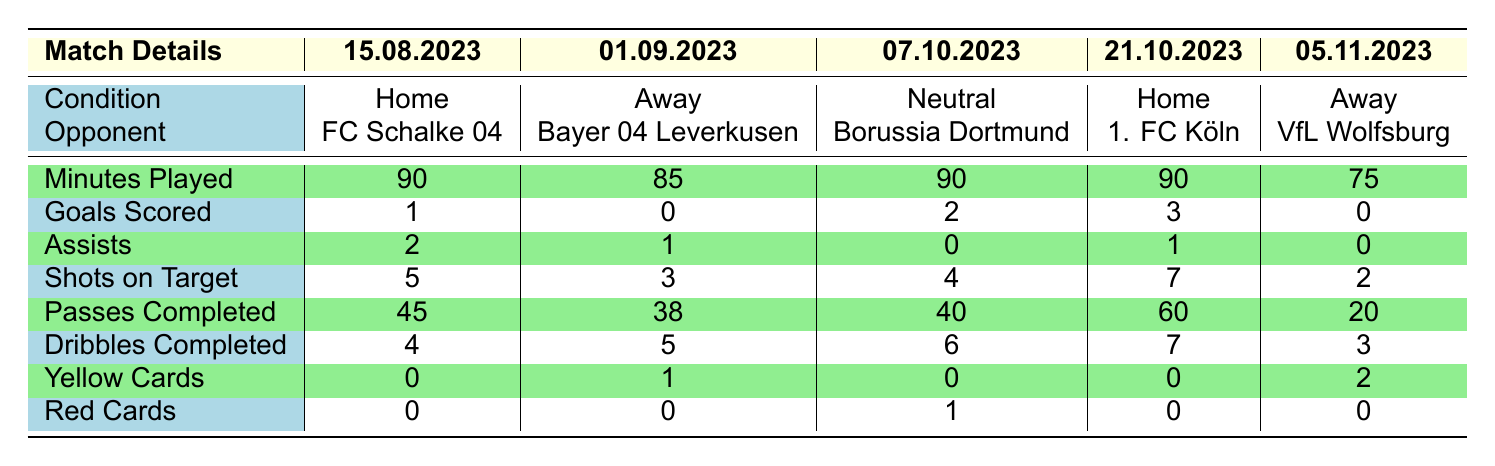What is the total number of goals scored by Jonas Kersken in home games? In the table, there are two home games listed. In the game on 2023-08-15, he scored 1 goal, and in the game on 2023-10-21, he scored 3 goals. So, total goals in home games = 1 + 3 = 4.
Answer: 4 How many assists did Jonas Kersken have in the away game against Bayer 04 Leverkusen? Looking at the relevant row for the away game on 2023-09-01, it shows that he had 1 assist in that match.
Answer: 1 What is the average number of shots on target across all the matches played? To find the average, we sum up all the shots on target: 5 + 3 + 4 + 7 + 2 = 21. There are 5 matches total, so the average = 21 / 5 = 4.2.
Answer: 4.2 Did he receive any red cards in the home game against FC Schalke 04? Checking the relevant row for the home game on 2023-08-15, it shows that he received 0 red cards.
Answer: No Which match condition resulted in the highest number of goals scored by Jonas Kersken? Looking at the goals scored in each match condition, he scored 0 goals in 2 away games, 4 in home games, and 2 in 1 neutral game. Thus, the highest was in home games with 4 goals.
Answer: Home Game What is the total number of yellow cards received by Jonas Kersken in the away matches? There are two away matches listed. In the game against Bayer 04 Leverkusen, he received 1 yellow card, and against VfL Wolfsburg, he received 2 yellow cards. Total yellow cards = 1 + 2 = 3.
Answer: 3 How many minutes did Jonas Kersken play in total across all matches? To find the total minutes played, we add the minutes from each match: 90 + 85 + 90 + 90 + 75 = 430.
Answer: 430 Was there any match where Jonas Kersken had both assists and yellow cards? Looking at each match, he had assists in one of the away games (1 assist and 1 yellow card) and in one home game (1 assist and 0 yellow cards), so the answer is yes.
Answer: Yes In how many matches did he complete more than 60 passes? In the table, only the home game against 1. FC Köln shows that he completed 60 passes. Therefore, the total matches are 1.
Answer: 1 